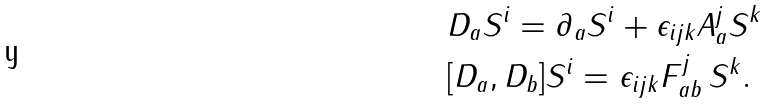<formula> <loc_0><loc_0><loc_500><loc_500>& D _ { a } S ^ { i } = \partial _ { a } S ^ { i } + \epsilon _ { i j k } A ^ { j } _ { a } S ^ { k } \\ & [ D _ { a } , D _ { b } ] S ^ { i } = \epsilon _ { i j k } F ^ { j } _ { a b } \, S ^ { k } .</formula> 